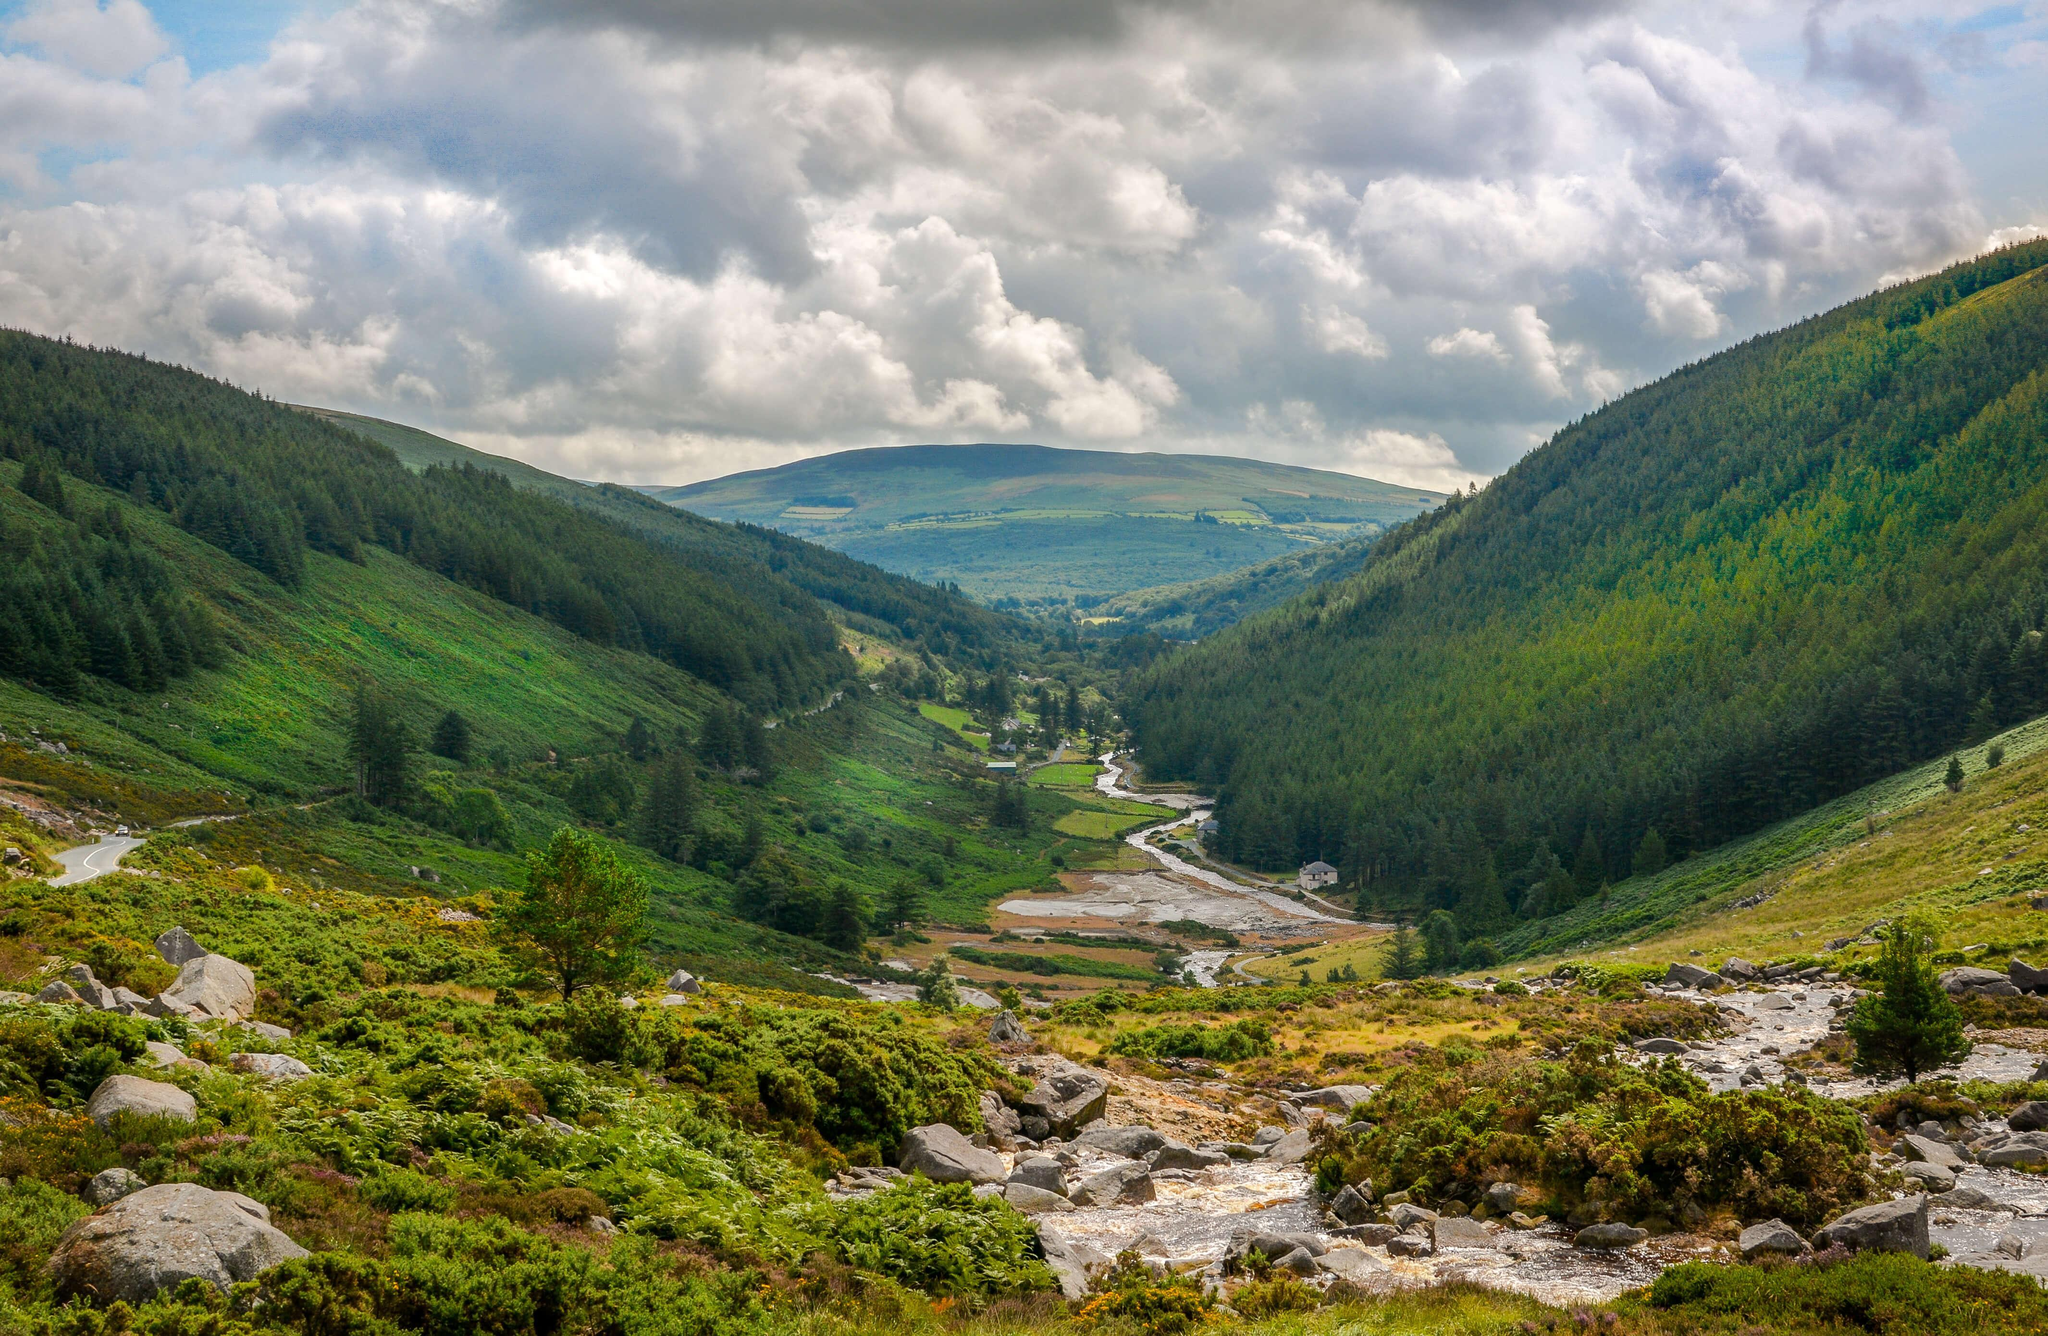What is in the image, mountains or city?
Answer the question with a short phrase. Mountains What is the predominant color in the image, green or red? green 